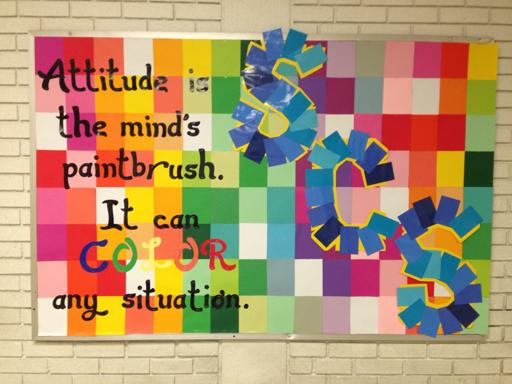What might the significance of the letter arrangements and the shapes used in the poster imply about the quote? The irregular arrangement of letters and the playful shapes in the poster imply a flexibility and creativity that parallels the message of the quote. Just as the text and its colorful backdrop are dynamic and engaging, the quote suggests that our attitude, when creatively and positively molded, can adapt to any circumstance, providing new perspectives and making experiences more vivid and engaging. 